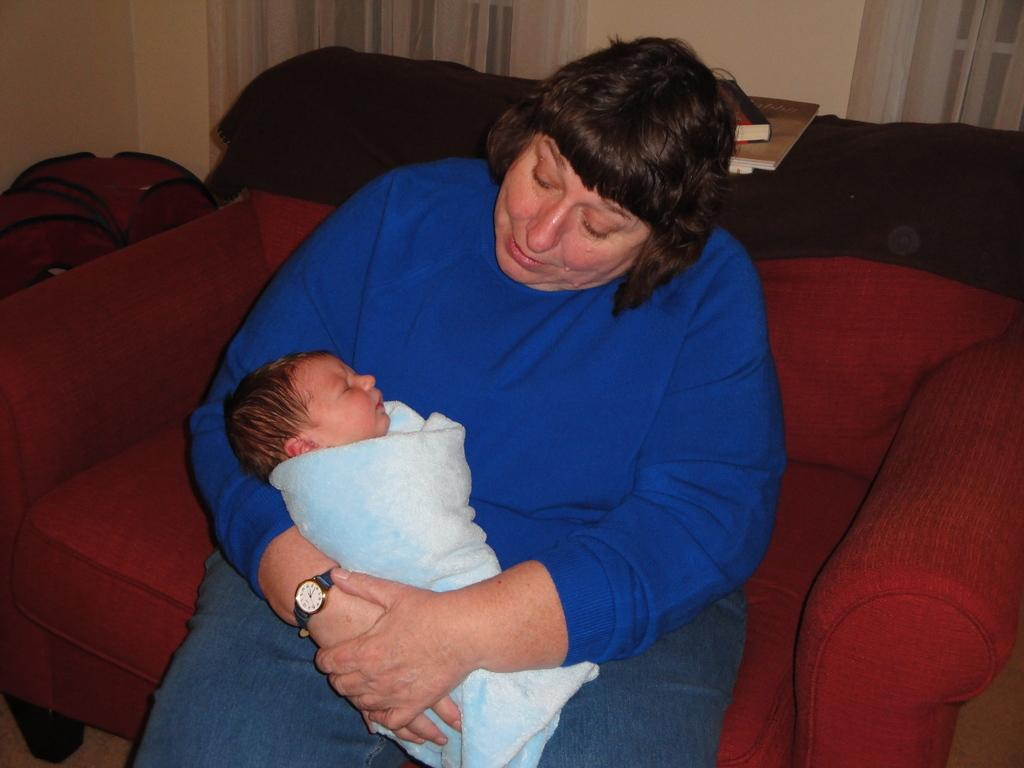Who is the main subject in the image? There is a woman in the image. What is the woman doing in the image? The woman is sitting on a sofa. Is there anyone else in the image? Yes, there is a baby on the woman. What can be seen in the background of the image? There is a wall, books, and some objects in the background of the image. Where is the harbor located in the image? There is no harbor present in the image. What type of animal is serving the woman in the image? There is no animal or servant present in the image. 